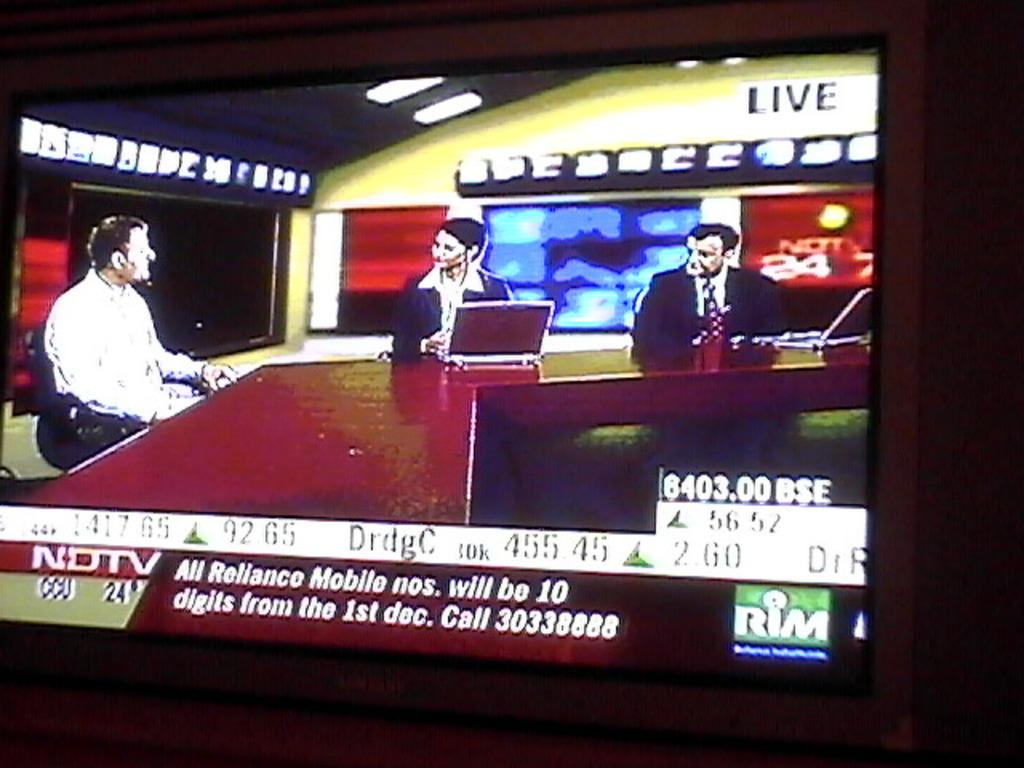<image>
Describe the image concisely. A flat screen is showing a news report with three anchors and says NDTV. 